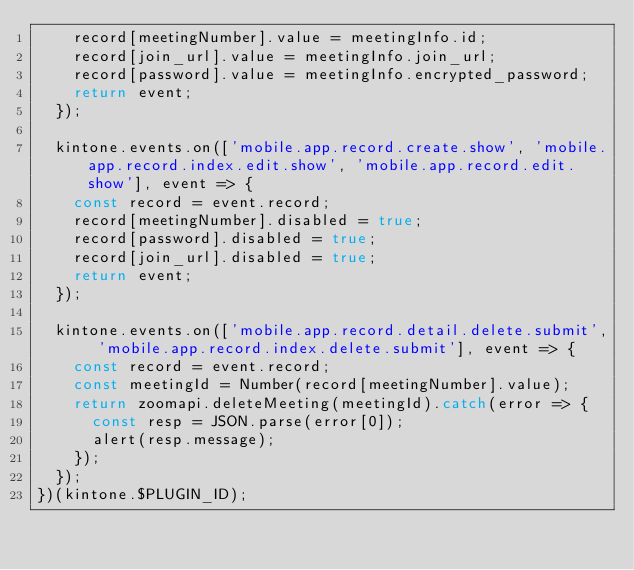<code> <loc_0><loc_0><loc_500><loc_500><_JavaScript_>    record[meetingNumber].value = meetingInfo.id;
    record[join_url].value = meetingInfo.join_url;
    record[password].value = meetingInfo.encrypted_password;
    return event;
  });

  kintone.events.on(['mobile.app.record.create.show', 'mobile.app.record.index.edit.show', 'mobile.app.record.edit.show'], event => {
    const record = event.record;
    record[meetingNumber].disabled = true;
    record[password].disabled = true;
    record[join_url].disabled = true;
    return event;
  });

  kintone.events.on(['mobile.app.record.detail.delete.submit', 'mobile.app.record.index.delete.submit'], event => {
    const record = event.record;
    const meetingId = Number(record[meetingNumber].value);
    return zoomapi.deleteMeeting(meetingId).catch(error => {
      const resp = JSON.parse(error[0]);
      alert(resp.message);
    });
  });
})(kintone.$PLUGIN_ID);
</code> 